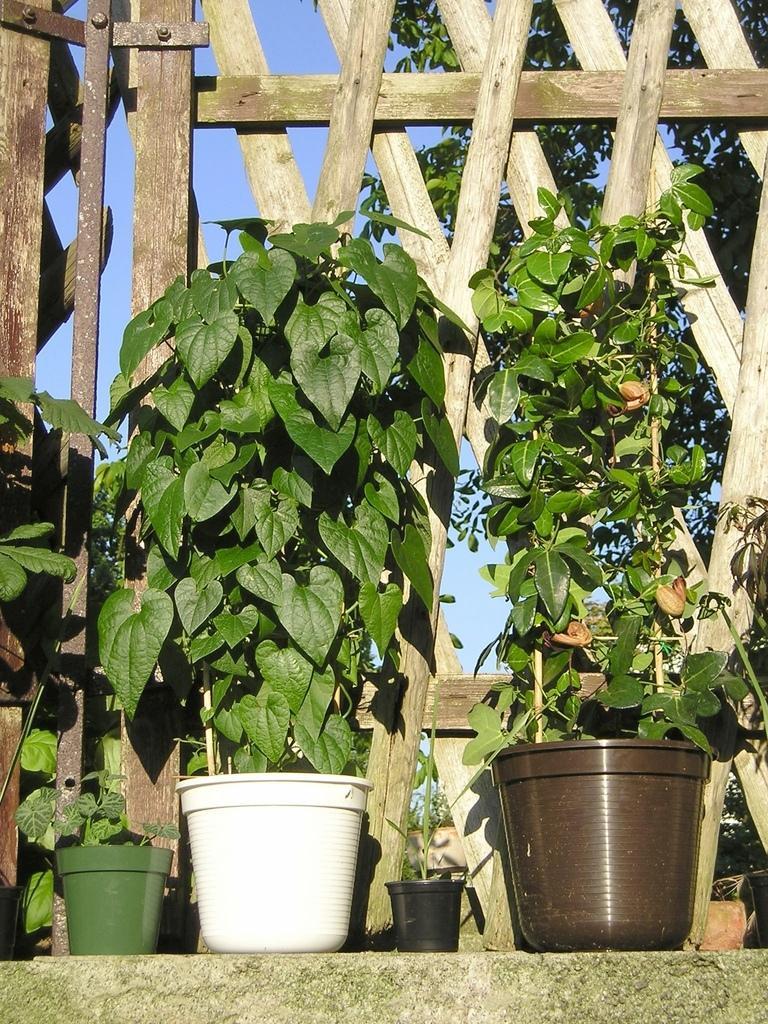Could you give a brief overview of what you see in this image? In the picture I can see plant pots and a wooden fence. In the background I can see trees and the sky. 